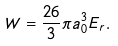<formula> <loc_0><loc_0><loc_500><loc_500>W = \frac { 2 6 } { 3 } \pi a _ { 0 } ^ { 3 } E _ { r } .</formula> 